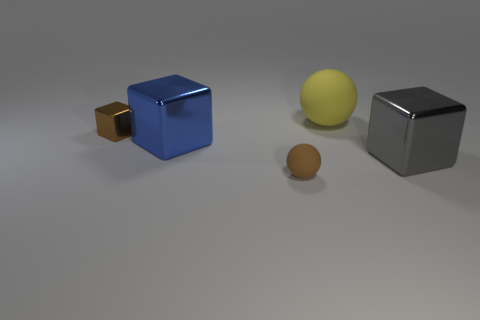Does the small shiny object have the same color as the big metallic cube right of the blue metallic block?
Ensure brevity in your answer.  No. Are there an equal number of blue shiny things that are in front of the big yellow matte ball and tiny brown metallic blocks right of the big gray object?
Provide a short and direct response. No. What number of big blue metallic objects are the same shape as the brown metallic thing?
Ensure brevity in your answer.  1. Are there any spheres?
Give a very brief answer. Yes. Is the material of the big gray block the same as the tiny brown object that is in front of the blue metallic block?
Offer a very short reply. No. What material is the blue object that is the same size as the yellow rubber ball?
Make the answer very short. Metal. Are there any objects that have the same material as the small cube?
Your answer should be very brief. Yes. There is a tiny brown shiny cube behind the rubber object that is in front of the big sphere; are there any matte things in front of it?
Offer a very short reply. Yes. What is the shape of the brown metallic object that is the same size as the brown rubber sphere?
Your answer should be very brief. Cube. There is a blue cube behind the small brown matte sphere; does it have the same size as the thing to the right of the big matte sphere?
Your answer should be compact. Yes. 